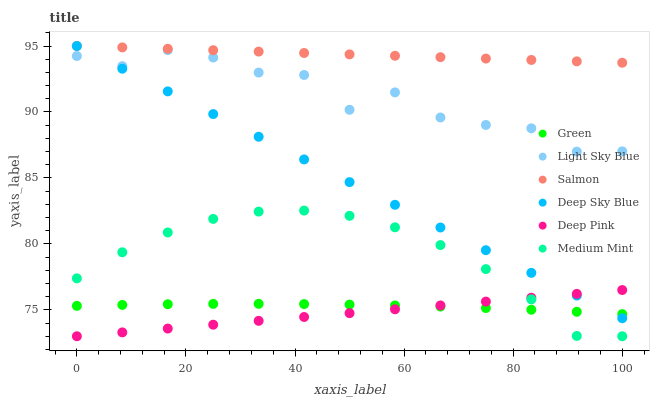Does Deep Pink have the minimum area under the curve?
Answer yes or no. Yes. Does Salmon have the maximum area under the curve?
Answer yes or no. Yes. Does Salmon have the minimum area under the curve?
Answer yes or no. No. Does Deep Pink have the maximum area under the curve?
Answer yes or no. No. Is Deep Sky Blue the smoothest?
Answer yes or no. Yes. Is Light Sky Blue the roughest?
Answer yes or no. Yes. Is Deep Pink the smoothest?
Answer yes or no. No. Is Deep Pink the roughest?
Answer yes or no. No. Does Medium Mint have the lowest value?
Answer yes or no. Yes. Does Salmon have the lowest value?
Answer yes or no. No. Does Deep Sky Blue have the highest value?
Answer yes or no. Yes. Does Deep Pink have the highest value?
Answer yes or no. No. Is Deep Pink less than Salmon?
Answer yes or no. Yes. Is Light Sky Blue greater than Medium Mint?
Answer yes or no. Yes. Does Deep Sky Blue intersect Deep Pink?
Answer yes or no. Yes. Is Deep Sky Blue less than Deep Pink?
Answer yes or no. No. Is Deep Sky Blue greater than Deep Pink?
Answer yes or no. No. Does Deep Pink intersect Salmon?
Answer yes or no. No. 